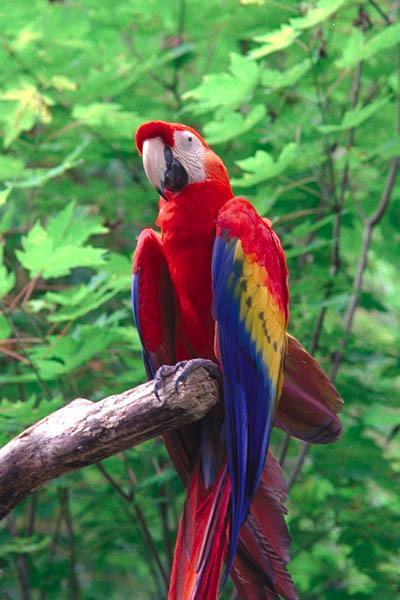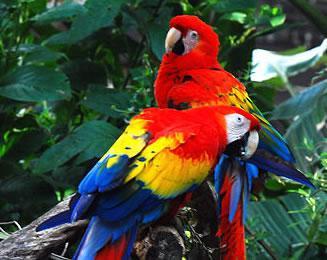The first image is the image on the left, the second image is the image on the right. Evaluate the accuracy of this statement regarding the images: "There are three birds in total". Is it true? Answer yes or no. Yes. The first image is the image on the left, the second image is the image on the right. Analyze the images presented: Is the assertion "The combined images show three colorful parrots, none with spread wings." valid? Answer yes or no. Yes. 